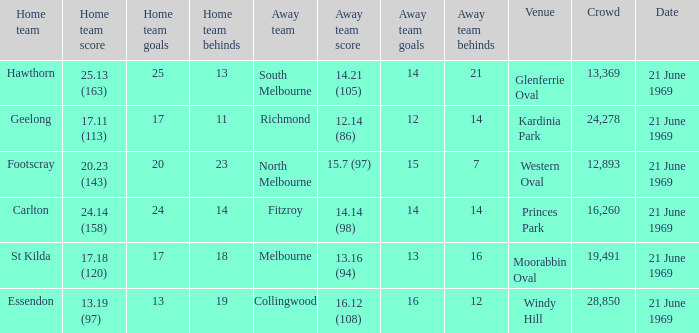When was there a game at Kardinia Park? 21 June 1969. 